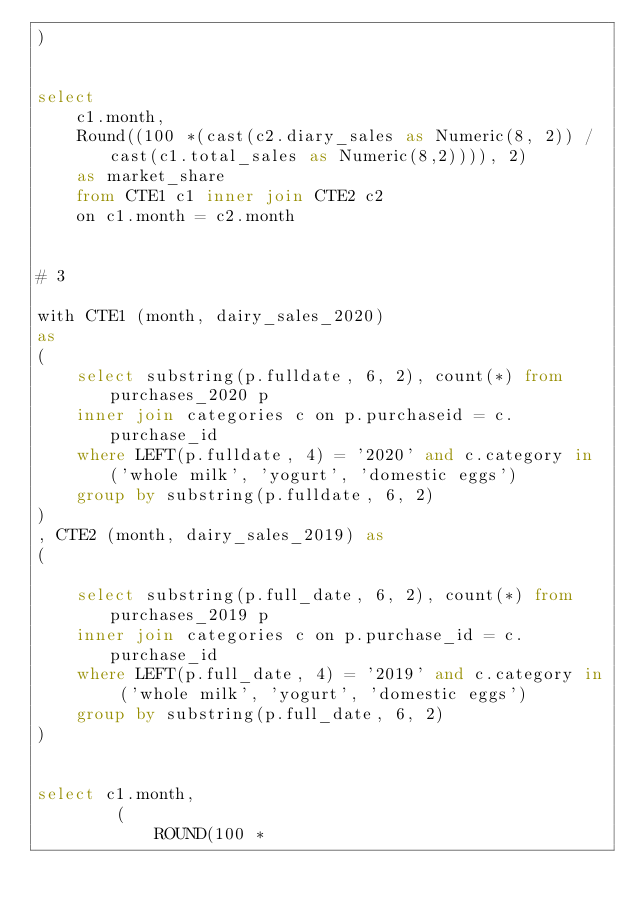Convert code to text. <code><loc_0><loc_0><loc_500><loc_500><_SQL_>)
    

select 
    c1.month, 
    Round((100 *(cast(c2.diary_sales as Numeric(8, 2)) / cast(c1.total_sales as Numeric(8,2)))), 2) 
    as market_share 
    from CTE1 c1 inner join CTE2 c2 
    on c1.month = c2.month
    
    
# 3 

with CTE1 (month, dairy_sales_2020)
as 
(
    select substring(p.fulldate, 6, 2), count(*) from purchases_2020 p 
    inner join categories c on p.purchaseid = c.purchase_id
    where LEFT(p.fulldate, 4) = '2020' and c.category in ('whole milk', 'yogurt', 'domestic eggs')
    group by substring(p.fulldate, 6, 2) 
)
, CTE2 (month, dairy_sales_2019) as 
(

    select substring(p.full_date, 6, 2), count(*) from purchases_2019 p 
    inner join categories c on p.purchase_id = c.purchase_id
    where LEFT(p.full_date, 4) = '2019' and c.category in ('whole milk', 'yogurt', 'domestic eggs')
    group by substring(p.full_date, 6, 2) 
)


select c1.month, 
        (
            ROUND(100 * </code> 